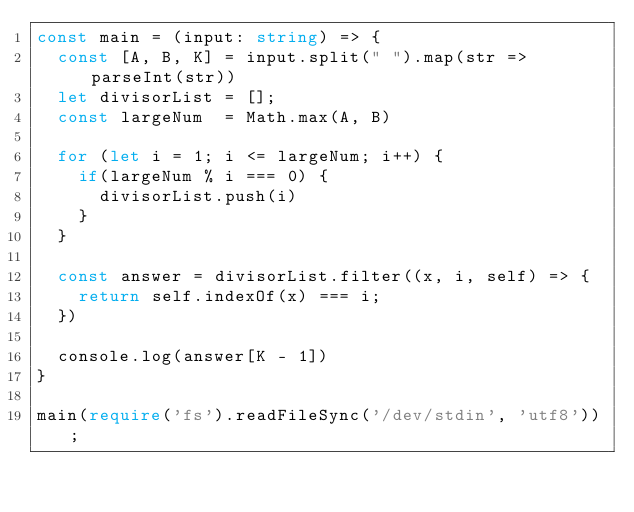Convert code to text. <code><loc_0><loc_0><loc_500><loc_500><_TypeScript_>const main = (input: string) => {
  const [A, B, K] = input.split(" ").map(str => parseInt(str))
  let divisorList = [];
  const largeNum  = Math.max(A, B)

  for (let i = 1; i <= largeNum; i++) {
    if(largeNum % i === 0) {
      divisorList.push(i)
    }
  }

  const answer = divisorList.filter((x, i, self) => {
    return self.indexOf(x) === i;
  })

  console.log(answer[K - 1])
}

main(require('fs').readFileSync('/dev/stdin', 'utf8'));
</code> 